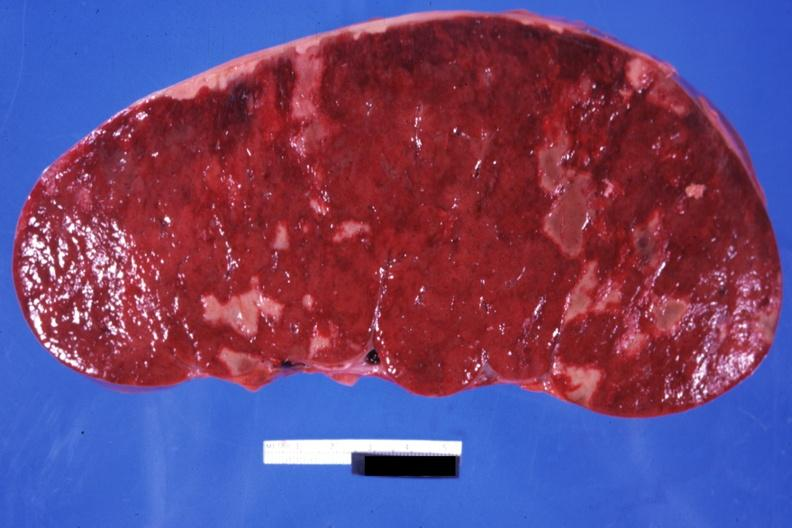s thymus present?
Answer the question using a single word or phrase. No 